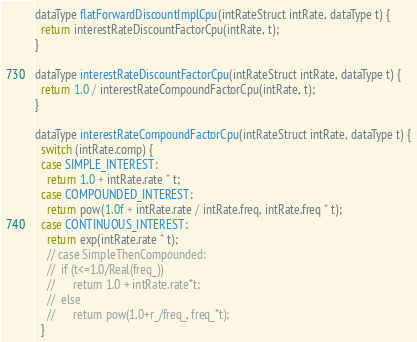Convert code to text. <code><loc_0><loc_0><loc_500><loc_500><_Cuda_>dataType flatForwardDiscountImplCpu(intRateStruct intRate, dataType t) {
  return interestRateDiscountFactorCpu(intRate, t);
}

dataType interestRateDiscountFactorCpu(intRateStruct intRate, dataType t) {
  return 1.0 / interestRateCompoundFactorCpu(intRate, t);
}

dataType interestRateCompoundFactorCpu(intRateStruct intRate, dataType t) {
  switch (intRate.comp) {
  case SIMPLE_INTEREST:
    return 1.0 + intRate.rate * t;
  case COMPOUNDED_INTEREST:
    return pow(1.0f + intRate.rate / intRate.freq, intRate.freq * t);
  case CONTINUOUS_INTEREST:
    return exp(intRate.rate * t);
    // case SimpleThenCompounded:
    //  if (t<=1.0/Real(freq_))
    //      return 1.0 + intRate.rate*t;
    //  else
    //      return pow(1.0+r_/freq_, freq_*t);
  }
</code> 